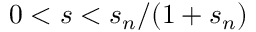Convert formula to latex. <formula><loc_0><loc_0><loc_500><loc_500>0 < s < s _ { n } / ( 1 + s _ { n } )</formula> 